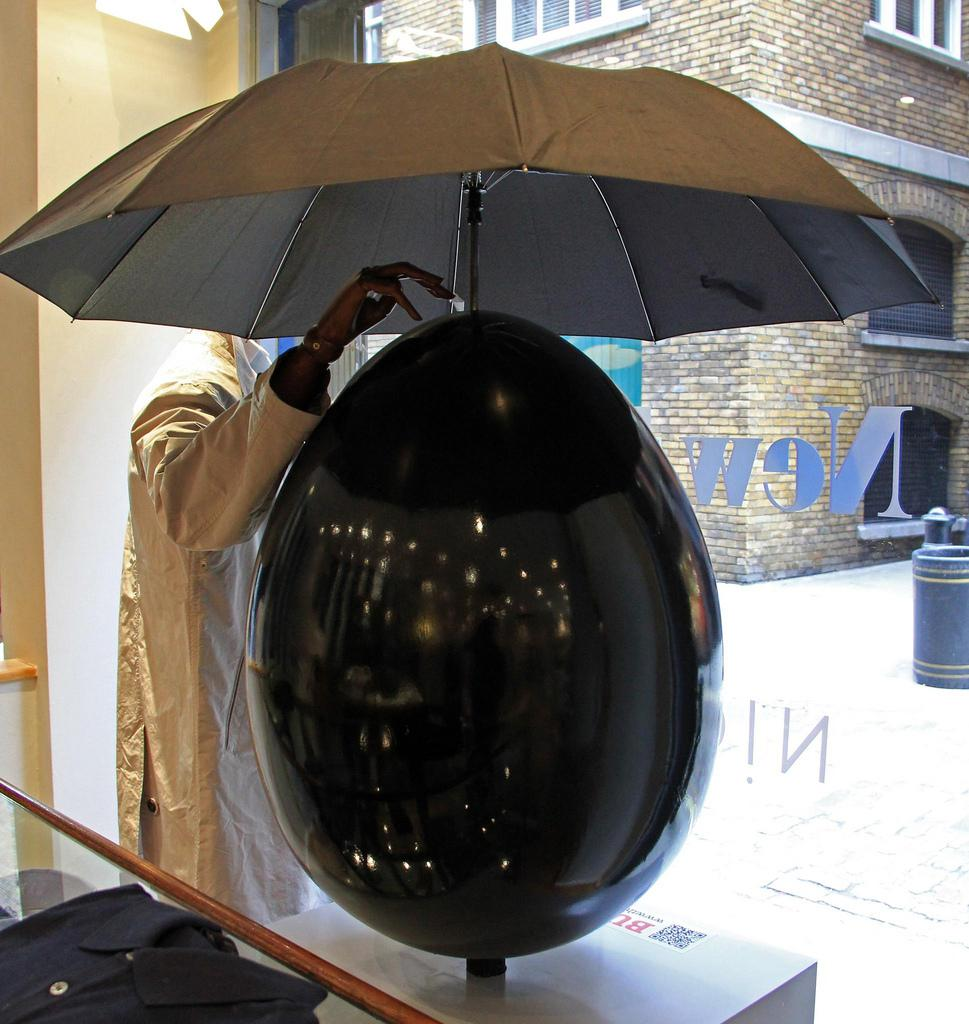Question: what color is the open umbrella?
Choices:
A. Blue.
B. Black.
C. Purple.
D. Orange.
Answer with the letter. Answer: B Question: what is in the display window?
Choices:
A. A pretty dress.
B. A wristwatch.
C. A large shiny egg.
D. A necklace.
Answer with the letter. Answer: C Question: what is laing behind the black egg?
Choices:
A. Pool balls.
B. A pool cue.
C. A coffee mug.
D. A glove.
Answer with the letter. Answer: B Question: what color is the umbrella?
Choices:
A. Teal.
B. Red.
C. Orange.
D. Tan.
Answer with the letter. Answer: D Question: where is this picture taken?
Choices:
A. Inside a store.
B. Inside the car.
C. At the mall.
D. In the bed.
Answer with the letter. Answer: A Question: who is touching the egg?
Choices:
A. The chicken.
B. The man.
C. The kid.
D. A mannequin.
Answer with the letter. Answer: D Question: what is the building outside made of?
Choices:
A. Steel.
B. Metal.
C. Brick.
D. Wood.
Answer with the letter. Answer: C Question: what color is the folded polo shirt?
Choices:
A. Red.
B. Forest Green.
C. Navy blue.
D. Canary Yellow.
Answer with the letter. Answer: C Question: what color is the mannequin's jacket?
Choices:
A. Brown.
B. Grey.
C. Navy Blue.
D. Beige.
Answer with the letter. Answer: D Question: where is a sticker?
Choices:
A. On my notebook.
B. On the bumper of his car.
C. On the wall.
D. On the shelf holding the egg with a qr code on it.
Answer with the letter. Answer: D Question: what can be seen through the window of the shop?
Choices:
A. Rows of candy.
B. Racks of clothing.
C. People eating.
D. A brick building.
Answer with the letter. Answer: D Question: what looks to be touching the black shiny egg?
Choices:
A. The dummy.
B. A little girl.
C. The old man.
D. A chicken.
Answer with the letter. Answer: A Question: where is the black shirt?
Choices:
A. In the foreground in a shop.
B. Folded in the drawer.
C. Hanging in the closet.
D. In my suitcase.
Answer with the letter. Answer: A Question: where can a brick building be seen?
Choices:
A. From car.
B. Through a window of a shop.
C. From the street.
D. From a bus.
Answer with the letter. Answer: B Question: what word in written on the window of a shop?
Choices:
A. Open.
B. Close.
C. New.
D. Come in.
Answer with the letter. Answer: C Question: where are the silver metal supports?
Choices:
A. In his hand.
B. In the ground.
C. In the house.
D. Inside of the umbrella.
Answer with the letter. Answer: D Question: what color stripes are on the trashcan?
Choices:
A. Yellow.
B. Red.
C. Blue.
D. Black.
Answer with the letter. Answer: A 